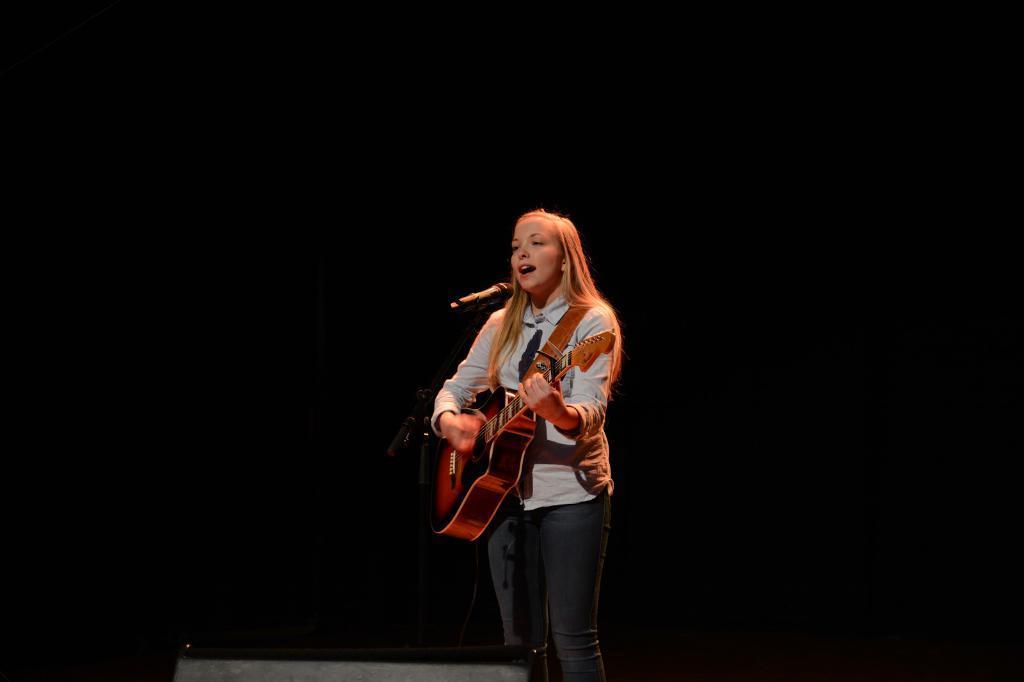Please provide a concise description of this image. This woman is playing guitar and singing in-front of mic. 